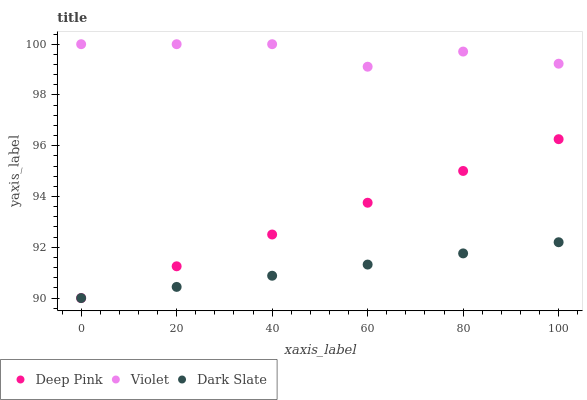Does Dark Slate have the minimum area under the curve?
Answer yes or no. Yes. Does Violet have the maximum area under the curve?
Answer yes or no. Yes. Does Deep Pink have the minimum area under the curve?
Answer yes or no. No. Does Deep Pink have the maximum area under the curve?
Answer yes or no. No. Is Deep Pink the smoothest?
Answer yes or no. Yes. Is Violet the roughest?
Answer yes or no. Yes. Is Violet the smoothest?
Answer yes or no. No. Is Deep Pink the roughest?
Answer yes or no. No. Does Dark Slate have the lowest value?
Answer yes or no. Yes. Does Violet have the lowest value?
Answer yes or no. No. Does Violet have the highest value?
Answer yes or no. Yes. Does Deep Pink have the highest value?
Answer yes or no. No. Is Deep Pink less than Violet?
Answer yes or no. Yes. Is Violet greater than Deep Pink?
Answer yes or no. Yes. Does Dark Slate intersect Deep Pink?
Answer yes or no. Yes. Is Dark Slate less than Deep Pink?
Answer yes or no. No. Is Dark Slate greater than Deep Pink?
Answer yes or no. No. Does Deep Pink intersect Violet?
Answer yes or no. No. 